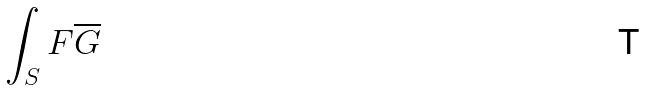<formula> <loc_0><loc_0><loc_500><loc_500>\int _ { S } F \overline { G }</formula> 